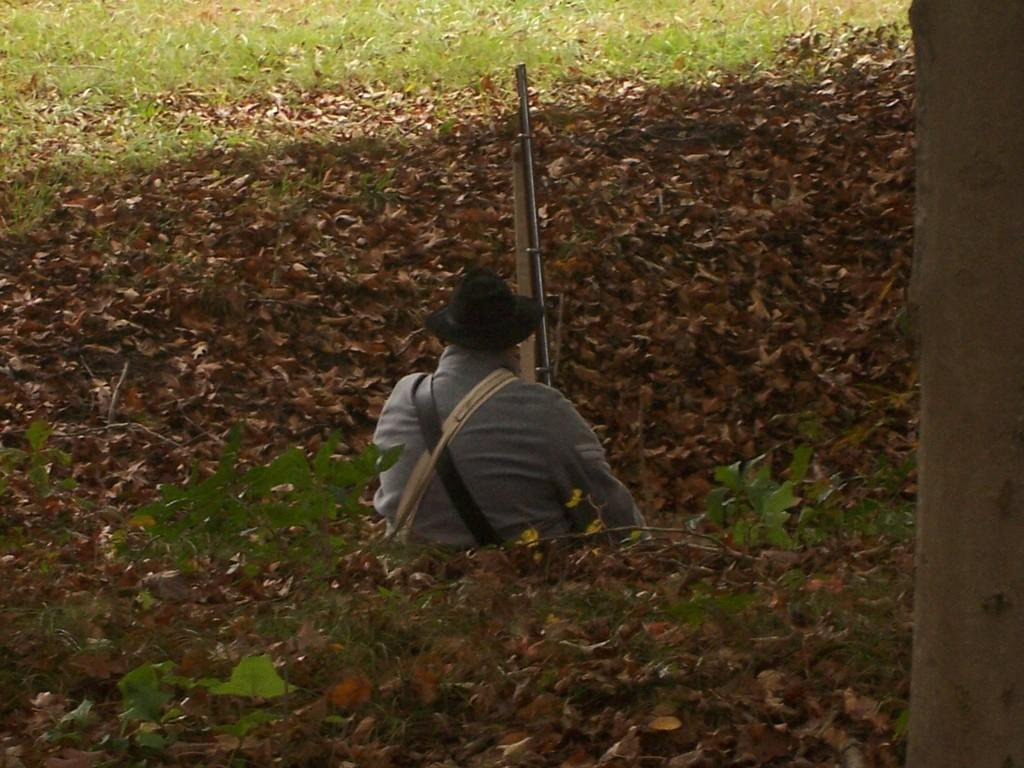What can be seen in the image? There is a person in the image. What is the person wearing? The person is wearing a hat. What is the person holding? The person is holding a gun. What type of terrain is visible in the image? There is grass, plants, and dried leaves on the ground in the image. What can be seen on the right side of the image? There is a tree trunk on the right side of the image. What channel is the person watching on the television in the image? There is no television present in the image, so it is not possible to determine what channel the person might be watching. 